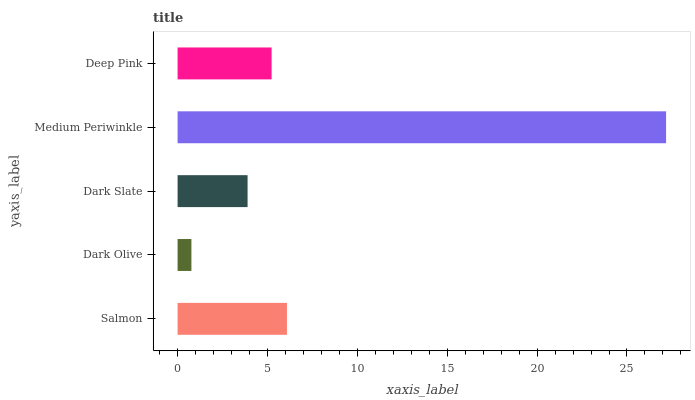Is Dark Olive the minimum?
Answer yes or no. Yes. Is Medium Periwinkle the maximum?
Answer yes or no. Yes. Is Dark Slate the minimum?
Answer yes or no. No. Is Dark Slate the maximum?
Answer yes or no. No. Is Dark Slate greater than Dark Olive?
Answer yes or no. Yes. Is Dark Olive less than Dark Slate?
Answer yes or no. Yes. Is Dark Olive greater than Dark Slate?
Answer yes or no. No. Is Dark Slate less than Dark Olive?
Answer yes or no. No. Is Deep Pink the high median?
Answer yes or no. Yes. Is Deep Pink the low median?
Answer yes or no. Yes. Is Dark Olive the high median?
Answer yes or no. No. Is Dark Olive the low median?
Answer yes or no. No. 